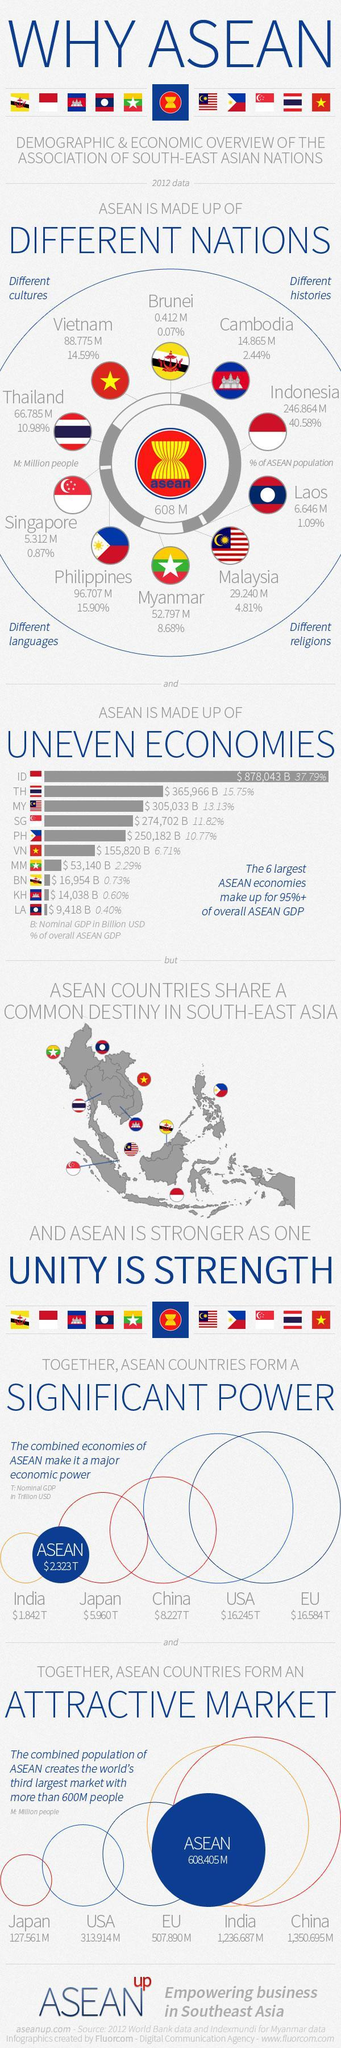What percentage of ASEAN made up of Brunei and Vietnam, taken together?
Answer the question with a short phrase. 14.66% What percentage of ASEAN made up of Malaysia and Myanmar, taken together? 13.49% 